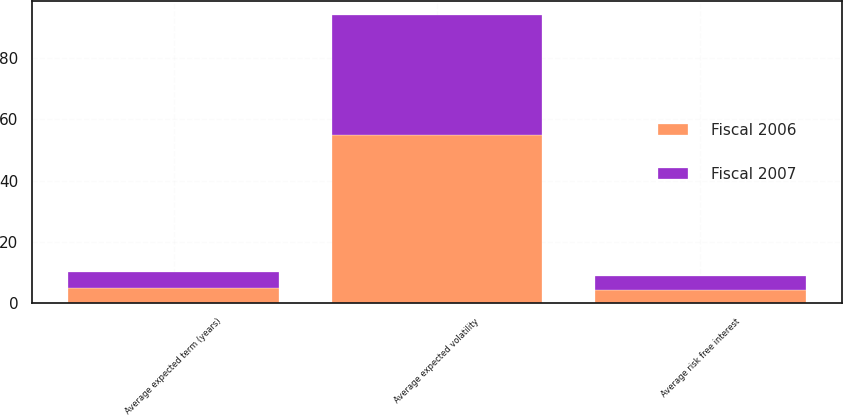Convert chart. <chart><loc_0><loc_0><loc_500><loc_500><stacked_bar_chart><ecel><fcel>Average risk free interest<fcel>Average expected term (years)<fcel>Average expected volatility<nl><fcel>Fiscal 2007<fcel>4.46<fcel>5.11<fcel>39<nl><fcel>Fiscal 2006<fcel>4.5<fcel>5<fcel>55<nl></chart> 